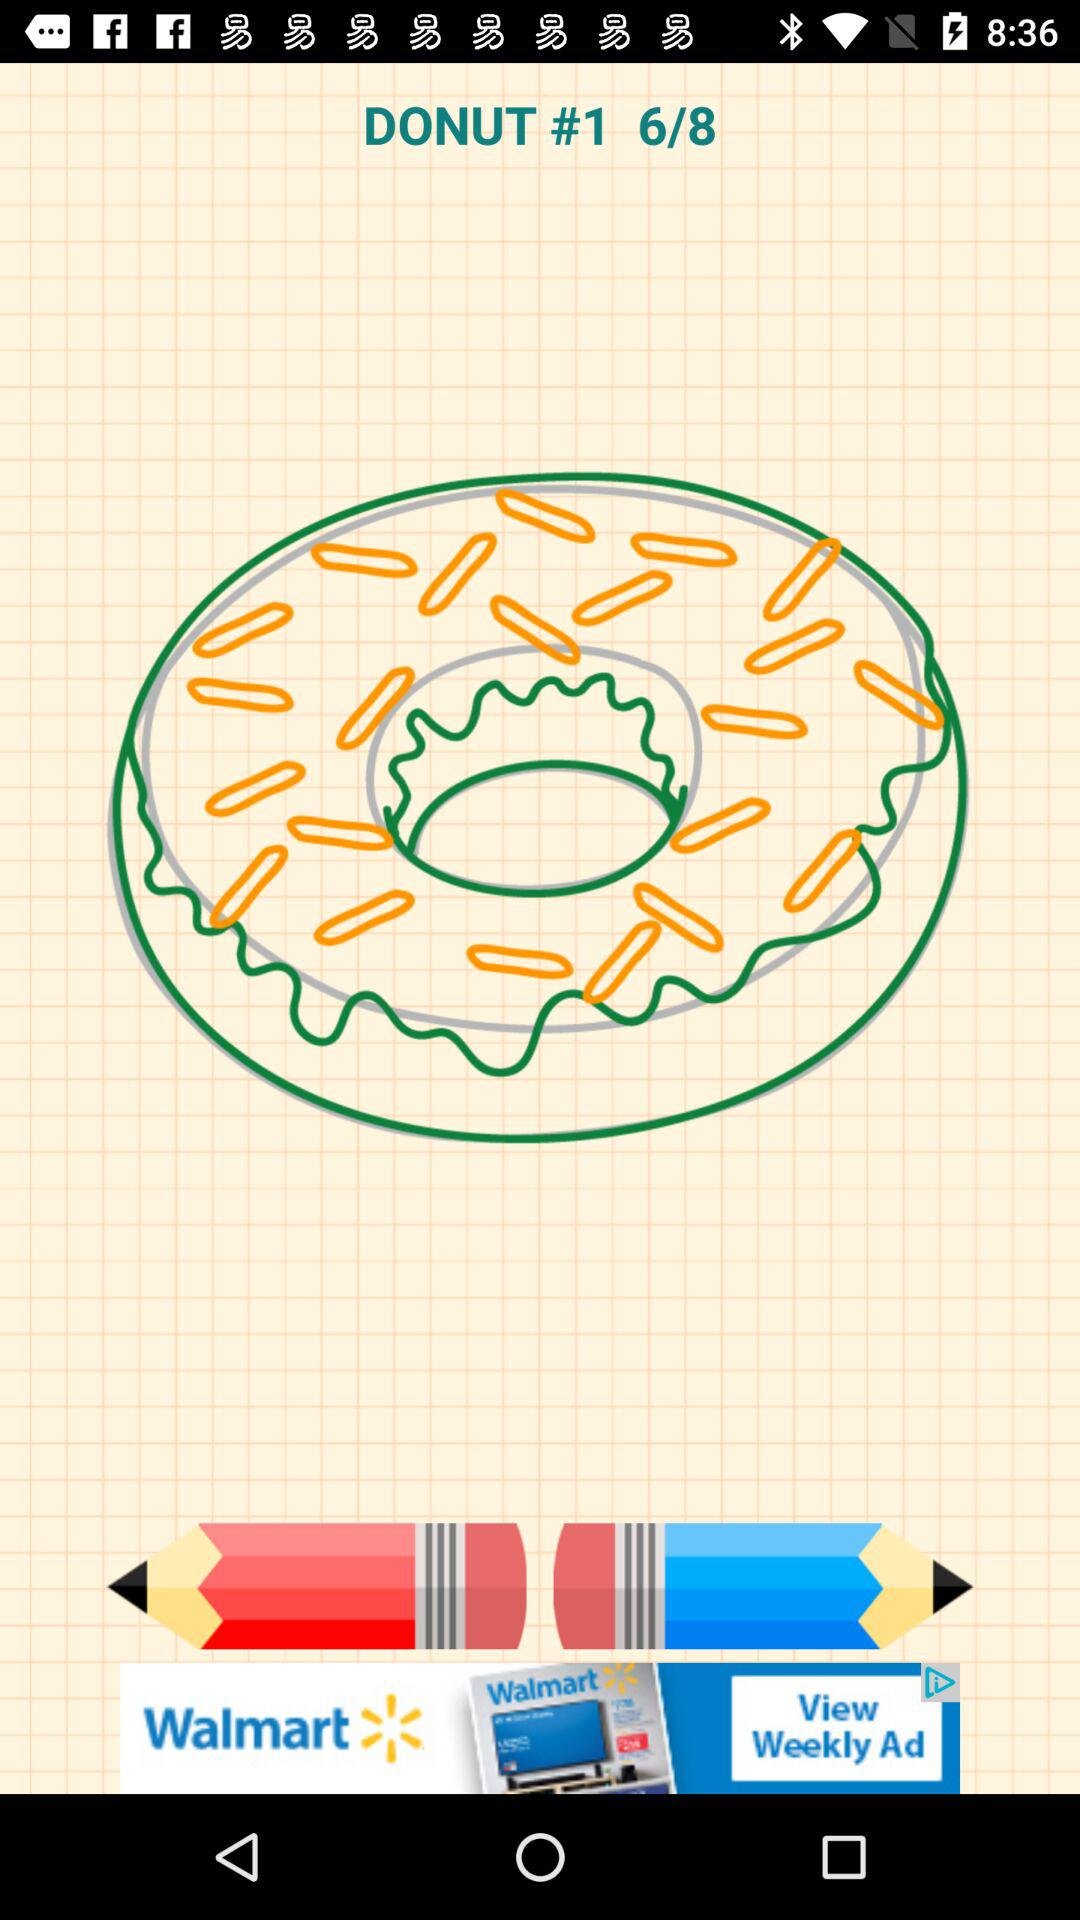Which item's drawing is this? The item is "DONUT". 